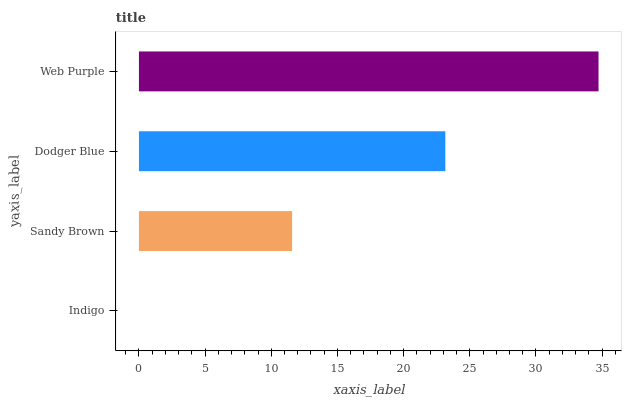Is Indigo the minimum?
Answer yes or no. Yes. Is Web Purple the maximum?
Answer yes or no. Yes. Is Sandy Brown the minimum?
Answer yes or no. No. Is Sandy Brown the maximum?
Answer yes or no. No. Is Sandy Brown greater than Indigo?
Answer yes or no. Yes. Is Indigo less than Sandy Brown?
Answer yes or no. Yes. Is Indigo greater than Sandy Brown?
Answer yes or no. No. Is Sandy Brown less than Indigo?
Answer yes or no. No. Is Dodger Blue the high median?
Answer yes or no. Yes. Is Sandy Brown the low median?
Answer yes or no. Yes. Is Web Purple the high median?
Answer yes or no. No. Is Web Purple the low median?
Answer yes or no. No. 